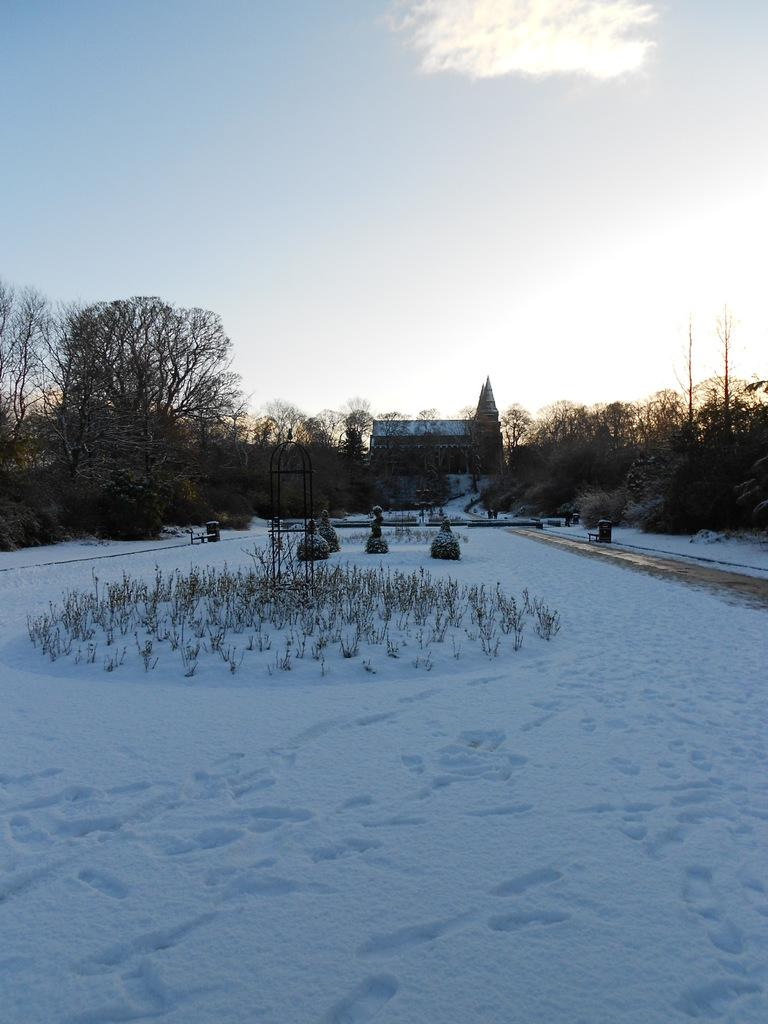What can be seen in the foreground of the image? There are plants and snow in the foreground of the image. What is located in the center of the image? There are trees, plants, and a house in the center of the image. What is visible at the top of the image? The sky is visible at the top of the image. What type of invention is being used to melt the snow in the image? There is no invention visible in the image; it simply shows plants and snow in the foreground. How much salt is present on the plants in the image? There is no salt present on the plants in the image. 